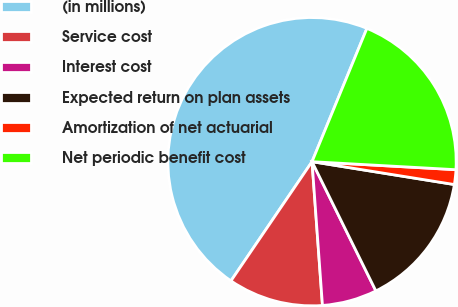Convert chart to OTSL. <chart><loc_0><loc_0><loc_500><loc_500><pie_chart><fcel>(in millions)<fcel>Service cost<fcel>Interest cost<fcel>Expected return on plan assets<fcel>Amortization of net actuarial<fcel>Net periodic benefit cost<nl><fcel>46.71%<fcel>10.66%<fcel>6.15%<fcel>15.16%<fcel>1.65%<fcel>19.67%<nl></chart> 